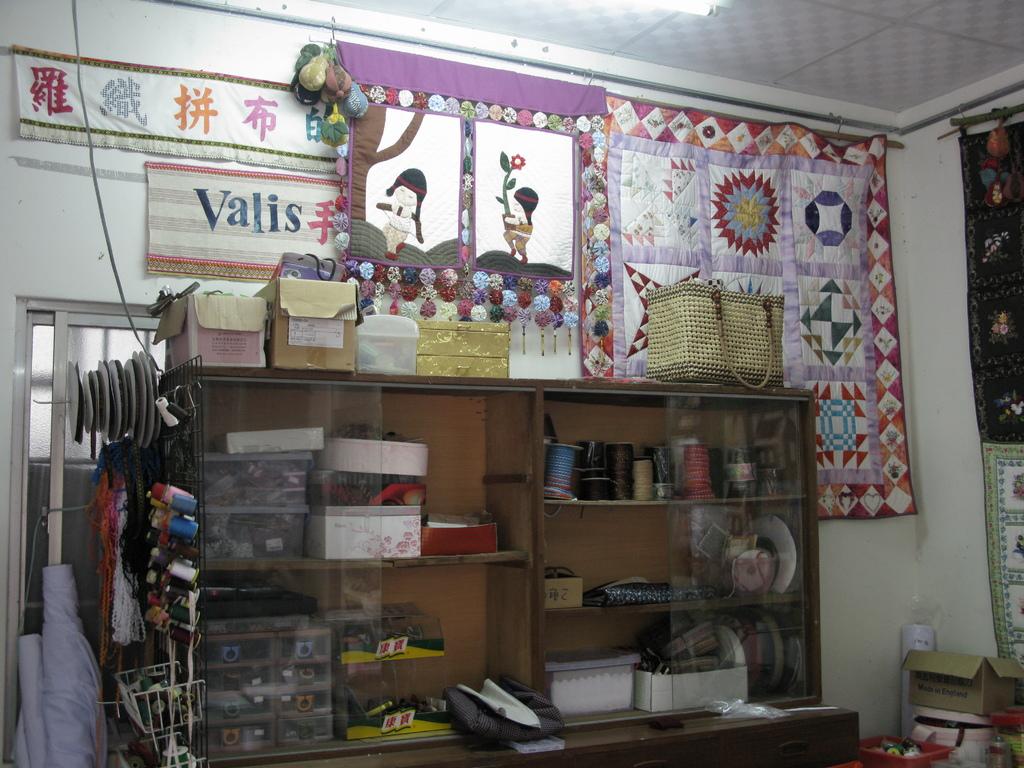What is written on the white and pink banner?
Make the answer very short. Valis. 